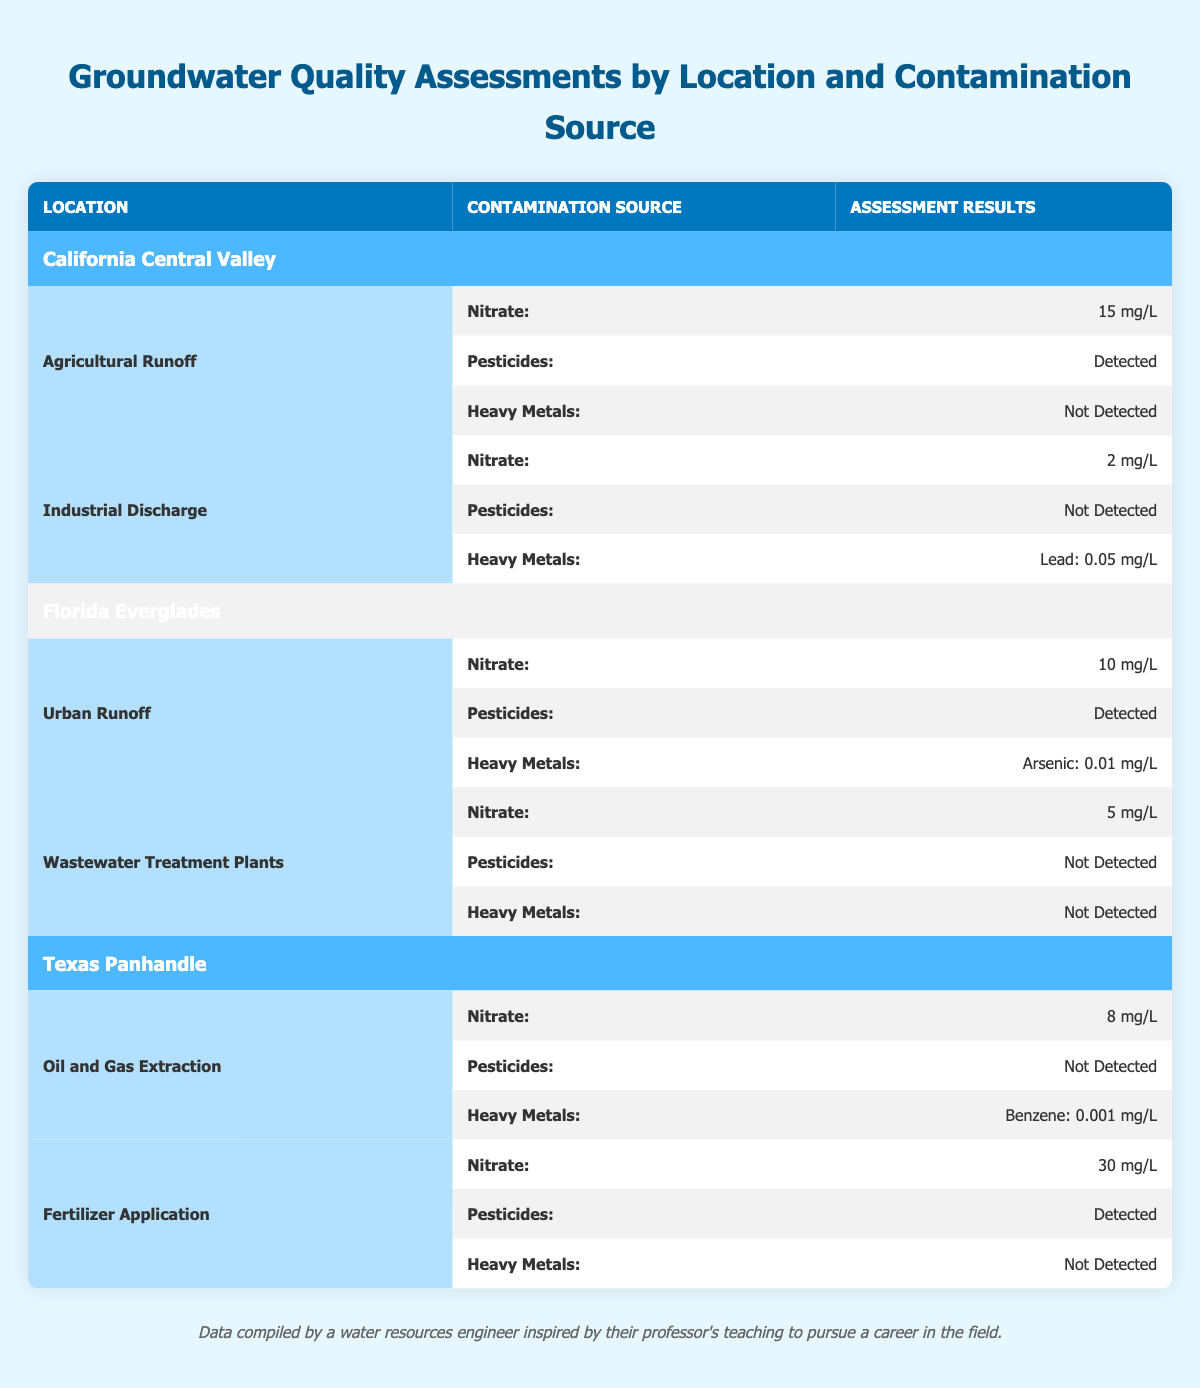What is the nitrate level for Agricultural Runoff in California Central Valley? The table shows that for Agricultural Runoff in California Central Valley, the assessment result for nitrate is listed as 15 mg/L.
Answer: 15 mg/L Is arsenic detected in Florida Everglades? The table states that under the contamination source of Urban Runoff in Florida Everglades, arsenic is detected at a level of 0.01 mg/L.
Answer: Yes What is the average nitrate level from all sources in Texas Panhandle? For Texas Panhandle, the nitrate levels are 8 mg/L from Oil and Gas Extraction and 30 mg/L from Fertilizer Application. The average is calculated as (8 + 30) / 2 = 19 mg/L.
Answer: 19 mg/L Are heavy metals detected in any contamination source in Florida Everglades? The table shows that under the Urban Runoff source heavy metals are detected as Arsenic: 0.01 mg/L, while under Wastewater Treatment Plants, heavy metals are not detected. Therefore, at least one source does have detected heavy metals.
Answer: Yes What contamination source has the highest nitrate level in California Central Valley? The nitrate levels for contamination sources in California Central Valley are 15 mg/L for Agricultural Runoff and 2 mg/L for Industrial Discharge. The highest level is thus from Agricultural Runoff at 15 mg/L.
Answer: Agricultural Runoff 